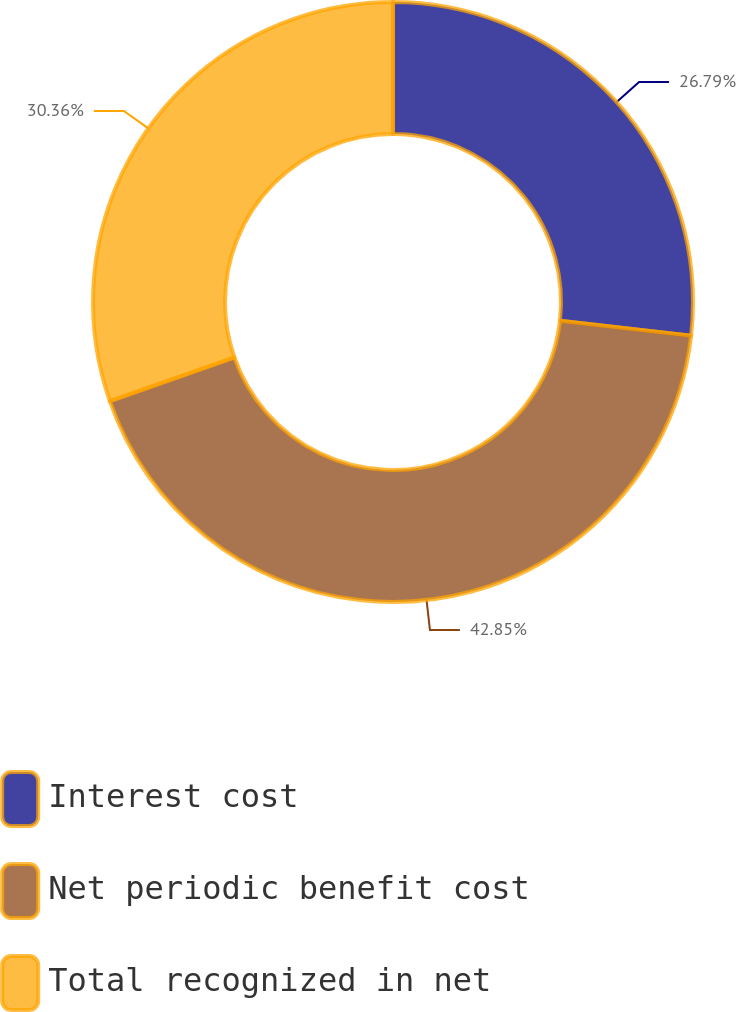Convert chart to OTSL. <chart><loc_0><loc_0><loc_500><loc_500><pie_chart><fcel>Interest cost<fcel>Net periodic benefit cost<fcel>Total recognized in net<nl><fcel>26.79%<fcel>42.86%<fcel>30.36%<nl></chart> 